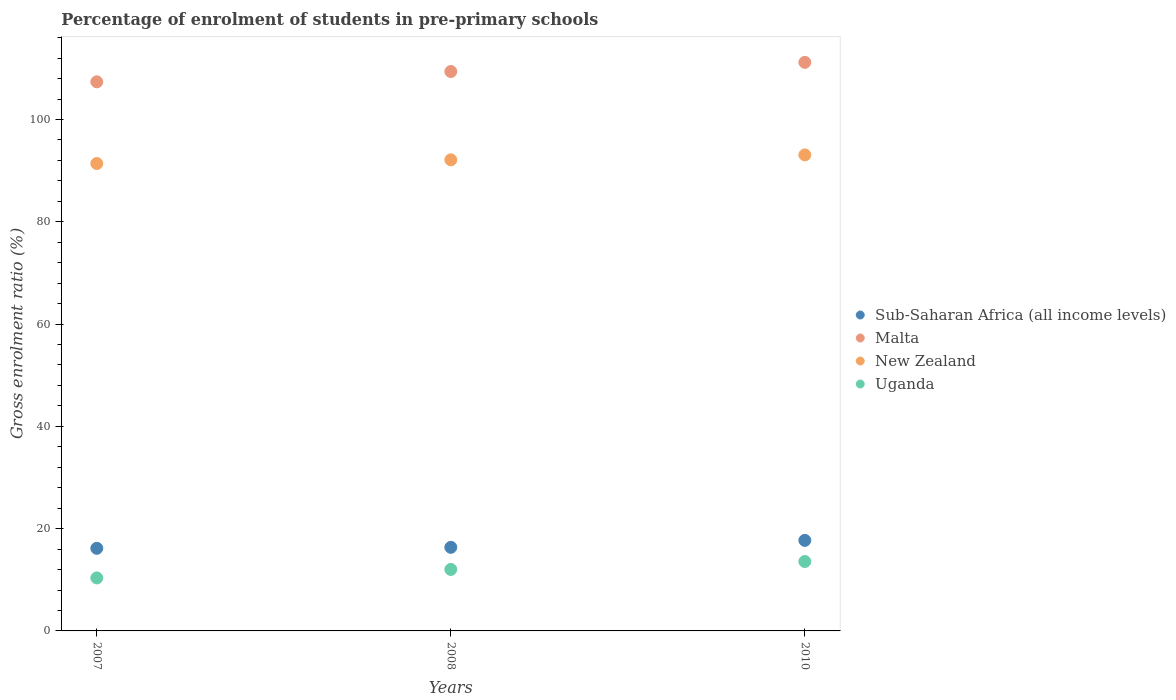How many different coloured dotlines are there?
Offer a very short reply. 4. What is the percentage of students enrolled in pre-primary schools in Uganda in 2010?
Ensure brevity in your answer.  13.57. Across all years, what is the maximum percentage of students enrolled in pre-primary schools in Uganda?
Provide a short and direct response. 13.57. Across all years, what is the minimum percentage of students enrolled in pre-primary schools in Sub-Saharan Africa (all income levels)?
Ensure brevity in your answer.  16.16. In which year was the percentage of students enrolled in pre-primary schools in New Zealand maximum?
Offer a terse response. 2010. What is the total percentage of students enrolled in pre-primary schools in Sub-Saharan Africa (all income levels) in the graph?
Provide a short and direct response. 50.2. What is the difference between the percentage of students enrolled in pre-primary schools in New Zealand in 2007 and that in 2008?
Your response must be concise. -0.72. What is the difference between the percentage of students enrolled in pre-primary schools in Uganda in 2010 and the percentage of students enrolled in pre-primary schools in Sub-Saharan Africa (all income levels) in 2007?
Keep it short and to the point. -2.58. What is the average percentage of students enrolled in pre-primary schools in Uganda per year?
Make the answer very short. 11.99. In the year 2007, what is the difference between the percentage of students enrolled in pre-primary schools in Sub-Saharan Africa (all income levels) and percentage of students enrolled in pre-primary schools in New Zealand?
Give a very brief answer. -75.24. What is the ratio of the percentage of students enrolled in pre-primary schools in Uganda in 2007 to that in 2008?
Make the answer very short. 0.86. Is the difference between the percentage of students enrolled in pre-primary schools in Sub-Saharan Africa (all income levels) in 2007 and 2008 greater than the difference between the percentage of students enrolled in pre-primary schools in New Zealand in 2007 and 2008?
Make the answer very short. Yes. What is the difference between the highest and the second highest percentage of students enrolled in pre-primary schools in Sub-Saharan Africa (all income levels)?
Give a very brief answer. 1.36. What is the difference between the highest and the lowest percentage of students enrolled in pre-primary schools in New Zealand?
Provide a succinct answer. 1.68. Is it the case that in every year, the sum of the percentage of students enrolled in pre-primary schools in Sub-Saharan Africa (all income levels) and percentage of students enrolled in pre-primary schools in New Zealand  is greater than the sum of percentage of students enrolled in pre-primary schools in Uganda and percentage of students enrolled in pre-primary schools in Malta?
Provide a short and direct response. No. Does the percentage of students enrolled in pre-primary schools in Malta monotonically increase over the years?
Ensure brevity in your answer.  Yes. Is the percentage of students enrolled in pre-primary schools in New Zealand strictly greater than the percentage of students enrolled in pre-primary schools in Uganda over the years?
Offer a terse response. Yes. Is the percentage of students enrolled in pre-primary schools in Uganda strictly less than the percentage of students enrolled in pre-primary schools in Sub-Saharan Africa (all income levels) over the years?
Ensure brevity in your answer.  Yes. Are the values on the major ticks of Y-axis written in scientific E-notation?
Your answer should be compact. No. Does the graph contain any zero values?
Give a very brief answer. No. Where does the legend appear in the graph?
Your answer should be very brief. Center right. What is the title of the graph?
Offer a terse response. Percentage of enrolment of students in pre-primary schools. What is the Gross enrolment ratio (%) of Sub-Saharan Africa (all income levels) in 2007?
Give a very brief answer. 16.16. What is the Gross enrolment ratio (%) of Malta in 2007?
Your response must be concise. 107.37. What is the Gross enrolment ratio (%) of New Zealand in 2007?
Provide a short and direct response. 91.4. What is the Gross enrolment ratio (%) of Uganda in 2007?
Make the answer very short. 10.36. What is the Gross enrolment ratio (%) of Sub-Saharan Africa (all income levels) in 2008?
Your answer should be very brief. 16.34. What is the Gross enrolment ratio (%) of Malta in 2008?
Give a very brief answer. 109.39. What is the Gross enrolment ratio (%) in New Zealand in 2008?
Your answer should be compact. 92.12. What is the Gross enrolment ratio (%) in Uganda in 2008?
Provide a short and direct response. 12.02. What is the Gross enrolment ratio (%) of Sub-Saharan Africa (all income levels) in 2010?
Your answer should be compact. 17.7. What is the Gross enrolment ratio (%) in Malta in 2010?
Give a very brief answer. 111.18. What is the Gross enrolment ratio (%) in New Zealand in 2010?
Your answer should be very brief. 93.08. What is the Gross enrolment ratio (%) of Uganda in 2010?
Keep it short and to the point. 13.57. Across all years, what is the maximum Gross enrolment ratio (%) of Sub-Saharan Africa (all income levels)?
Keep it short and to the point. 17.7. Across all years, what is the maximum Gross enrolment ratio (%) in Malta?
Offer a very short reply. 111.18. Across all years, what is the maximum Gross enrolment ratio (%) of New Zealand?
Ensure brevity in your answer.  93.08. Across all years, what is the maximum Gross enrolment ratio (%) of Uganda?
Give a very brief answer. 13.57. Across all years, what is the minimum Gross enrolment ratio (%) in Sub-Saharan Africa (all income levels)?
Offer a terse response. 16.16. Across all years, what is the minimum Gross enrolment ratio (%) of Malta?
Your answer should be very brief. 107.37. Across all years, what is the minimum Gross enrolment ratio (%) in New Zealand?
Offer a terse response. 91.4. Across all years, what is the minimum Gross enrolment ratio (%) of Uganda?
Your response must be concise. 10.36. What is the total Gross enrolment ratio (%) in Sub-Saharan Africa (all income levels) in the graph?
Provide a succinct answer. 50.2. What is the total Gross enrolment ratio (%) in Malta in the graph?
Provide a short and direct response. 327.93. What is the total Gross enrolment ratio (%) in New Zealand in the graph?
Your answer should be compact. 276.6. What is the total Gross enrolment ratio (%) of Uganda in the graph?
Provide a succinct answer. 35.96. What is the difference between the Gross enrolment ratio (%) of Sub-Saharan Africa (all income levels) in 2007 and that in 2008?
Your answer should be very brief. -0.19. What is the difference between the Gross enrolment ratio (%) in Malta in 2007 and that in 2008?
Provide a short and direct response. -2.02. What is the difference between the Gross enrolment ratio (%) in New Zealand in 2007 and that in 2008?
Keep it short and to the point. -0.72. What is the difference between the Gross enrolment ratio (%) in Uganda in 2007 and that in 2008?
Provide a succinct answer. -1.66. What is the difference between the Gross enrolment ratio (%) in Sub-Saharan Africa (all income levels) in 2007 and that in 2010?
Make the answer very short. -1.55. What is the difference between the Gross enrolment ratio (%) in Malta in 2007 and that in 2010?
Ensure brevity in your answer.  -3.81. What is the difference between the Gross enrolment ratio (%) in New Zealand in 2007 and that in 2010?
Make the answer very short. -1.68. What is the difference between the Gross enrolment ratio (%) in Uganda in 2007 and that in 2010?
Offer a terse response. -3.21. What is the difference between the Gross enrolment ratio (%) in Sub-Saharan Africa (all income levels) in 2008 and that in 2010?
Ensure brevity in your answer.  -1.36. What is the difference between the Gross enrolment ratio (%) in Malta in 2008 and that in 2010?
Make the answer very short. -1.79. What is the difference between the Gross enrolment ratio (%) in New Zealand in 2008 and that in 2010?
Offer a very short reply. -0.96. What is the difference between the Gross enrolment ratio (%) of Uganda in 2008 and that in 2010?
Provide a short and direct response. -1.55. What is the difference between the Gross enrolment ratio (%) of Sub-Saharan Africa (all income levels) in 2007 and the Gross enrolment ratio (%) of Malta in 2008?
Offer a terse response. -93.23. What is the difference between the Gross enrolment ratio (%) in Sub-Saharan Africa (all income levels) in 2007 and the Gross enrolment ratio (%) in New Zealand in 2008?
Your answer should be very brief. -75.96. What is the difference between the Gross enrolment ratio (%) of Sub-Saharan Africa (all income levels) in 2007 and the Gross enrolment ratio (%) of Uganda in 2008?
Ensure brevity in your answer.  4.13. What is the difference between the Gross enrolment ratio (%) of Malta in 2007 and the Gross enrolment ratio (%) of New Zealand in 2008?
Offer a terse response. 15.25. What is the difference between the Gross enrolment ratio (%) of Malta in 2007 and the Gross enrolment ratio (%) of Uganda in 2008?
Offer a very short reply. 95.35. What is the difference between the Gross enrolment ratio (%) in New Zealand in 2007 and the Gross enrolment ratio (%) in Uganda in 2008?
Keep it short and to the point. 79.37. What is the difference between the Gross enrolment ratio (%) in Sub-Saharan Africa (all income levels) in 2007 and the Gross enrolment ratio (%) in Malta in 2010?
Offer a very short reply. -95.02. What is the difference between the Gross enrolment ratio (%) in Sub-Saharan Africa (all income levels) in 2007 and the Gross enrolment ratio (%) in New Zealand in 2010?
Your answer should be very brief. -76.93. What is the difference between the Gross enrolment ratio (%) of Sub-Saharan Africa (all income levels) in 2007 and the Gross enrolment ratio (%) of Uganda in 2010?
Give a very brief answer. 2.58. What is the difference between the Gross enrolment ratio (%) of Malta in 2007 and the Gross enrolment ratio (%) of New Zealand in 2010?
Give a very brief answer. 14.29. What is the difference between the Gross enrolment ratio (%) in Malta in 2007 and the Gross enrolment ratio (%) in Uganda in 2010?
Your answer should be compact. 93.8. What is the difference between the Gross enrolment ratio (%) in New Zealand in 2007 and the Gross enrolment ratio (%) in Uganda in 2010?
Provide a succinct answer. 77.83. What is the difference between the Gross enrolment ratio (%) in Sub-Saharan Africa (all income levels) in 2008 and the Gross enrolment ratio (%) in Malta in 2010?
Provide a short and direct response. -94.83. What is the difference between the Gross enrolment ratio (%) of Sub-Saharan Africa (all income levels) in 2008 and the Gross enrolment ratio (%) of New Zealand in 2010?
Offer a very short reply. -76.74. What is the difference between the Gross enrolment ratio (%) of Sub-Saharan Africa (all income levels) in 2008 and the Gross enrolment ratio (%) of Uganda in 2010?
Offer a very short reply. 2.77. What is the difference between the Gross enrolment ratio (%) of Malta in 2008 and the Gross enrolment ratio (%) of New Zealand in 2010?
Keep it short and to the point. 16.31. What is the difference between the Gross enrolment ratio (%) in Malta in 2008 and the Gross enrolment ratio (%) in Uganda in 2010?
Keep it short and to the point. 95.82. What is the difference between the Gross enrolment ratio (%) of New Zealand in 2008 and the Gross enrolment ratio (%) of Uganda in 2010?
Your answer should be very brief. 78.55. What is the average Gross enrolment ratio (%) of Sub-Saharan Africa (all income levels) per year?
Make the answer very short. 16.73. What is the average Gross enrolment ratio (%) of Malta per year?
Provide a short and direct response. 109.31. What is the average Gross enrolment ratio (%) of New Zealand per year?
Keep it short and to the point. 92.2. What is the average Gross enrolment ratio (%) of Uganda per year?
Your answer should be very brief. 11.99. In the year 2007, what is the difference between the Gross enrolment ratio (%) in Sub-Saharan Africa (all income levels) and Gross enrolment ratio (%) in Malta?
Provide a short and direct response. -91.21. In the year 2007, what is the difference between the Gross enrolment ratio (%) of Sub-Saharan Africa (all income levels) and Gross enrolment ratio (%) of New Zealand?
Your answer should be compact. -75.24. In the year 2007, what is the difference between the Gross enrolment ratio (%) in Sub-Saharan Africa (all income levels) and Gross enrolment ratio (%) in Uganda?
Ensure brevity in your answer.  5.79. In the year 2007, what is the difference between the Gross enrolment ratio (%) in Malta and Gross enrolment ratio (%) in New Zealand?
Your answer should be compact. 15.97. In the year 2007, what is the difference between the Gross enrolment ratio (%) in Malta and Gross enrolment ratio (%) in Uganda?
Make the answer very short. 97.01. In the year 2007, what is the difference between the Gross enrolment ratio (%) of New Zealand and Gross enrolment ratio (%) of Uganda?
Give a very brief answer. 81.03. In the year 2008, what is the difference between the Gross enrolment ratio (%) of Sub-Saharan Africa (all income levels) and Gross enrolment ratio (%) of Malta?
Provide a short and direct response. -93.04. In the year 2008, what is the difference between the Gross enrolment ratio (%) in Sub-Saharan Africa (all income levels) and Gross enrolment ratio (%) in New Zealand?
Offer a very short reply. -75.77. In the year 2008, what is the difference between the Gross enrolment ratio (%) of Sub-Saharan Africa (all income levels) and Gross enrolment ratio (%) of Uganda?
Your answer should be very brief. 4.32. In the year 2008, what is the difference between the Gross enrolment ratio (%) of Malta and Gross enrolment ratio (%) of New Zealand?
Keep it short and to the point. 17.27. In the year 2008, what is the difference between the Gross enrolment ratio (%) of Malta and Gross enrolment ratio (%) of Uganda?
Keep it short and to the point. 97.36. In the year 2008, what is the difference between the Gross enrolment ratio (%) in New Zealand and Gross enrolment ratio (%) in Uganda?
Provide a succinct answer. 80.1. In the year 2010, what is the difference between the Gross enrolment ratio (%) in Sub-Saharan Africa (all income levels) and Gross enrolment ratio (%) in Malta?
Offer a very short reply. -93.47. In the year 2010, what is the difference between the Gross enrolment ratio (%) in Sub-Saharan Africa (all income levels) and Gross enrolment ratio (%) in New Zealand?
Offer a very short reply. -75.38. In the year 2010, what is the difference between the Gross enrolment ratio (%) in Sub-Saharan Africa (all income levels) and Gross enrolment ratio (%) in Uganda?
Offer a very short reply. 4.13. In the year 2010, what is the difference between the Gross enrolment ratio (%) in Malta and Gross enrolment ratio (%) in New Zealand?
Your answer should be very brief. 18.1. In the year 2010, what is the difference between the Gross enrolment ratio (%) in Malta and Gross enrolment ratio (%) in Uganda?
Your answer should be very brief. 97.61. In the year 2010, what is the difference between the Gross enrolment ratio (%) in New Zealand and Gross enrolment ratio (%) in Uganda?
Provide a short and direct response. 79.51. What is the ratio of the Gross enrolment ratio (%) in Malta in 2007 to that in 2008?
Your answer should be compact. 0.98. What is the ratio of the Gross enrolment ratio (%) in Uganda in 2007 to that in 2008?
Provide a succinct answer. 0.86. What is the ratio of the Gross enrolment ratio (%) in Sub-Saharan Africa (all income levels) in 2007 to that in 2010?
Keep it short and to the point. 0.91. What is the ratio of the Gross enrolment ratio (%) of Malta in 2007 to that in 2010?
Provide a short and direct response. 0.97. What is the ratio of the Gross enrolment ratio (%) of New Zealand in 2007 to that in 2010?
Keep it short and to the point. 0.98. What is the ratio of the Gross enrolment ratio (%) of Uganda in 2007 to that in 2010?
Offer a very short reply. 0.76. What is the ratio of the Gross enrolment ratio (%) in Sub-Saharan Africa (all income levels) in 2008 to that in 2010?
Make the answer very short. 0.92. What is the ratio of the Gross enrolment ratio (%) in Malta in 2008 to that in 2010?
Your answer should be compact. 0.98. What is the ratio of the Gross enrolment ratio (%) of Uganda in 2008 to that in 2010?
Your answer should be compact. 0.89. What is the difference between the highest and the second highest Gross enrolment ratio (%) in Sub-Saharan Africa (all income levels)?
Offer a very short reply. 1.36. What is the difference between the highest and the second highest Gross enrolment ratio (%) of Malta?
Your response must be concise. 1.79. What is the difference between the highest and the second highest Gross enrolment ratio (%) of New Zealand?
Your answer should be very brief. 0.96. What is the difference between the highest and the second highest Gross enrolment ratio (%) of Uganda?
Your response must be concise. 1.55. What is the difference between the highest and the lowest Gross enrolment ratio (%) in Sub-Saharan Africa (all income levels)?
Provide a succinct answer. 1.55. What is the difference between the highest and the lowest Gross enrolment ratio (%) in Malta?
Make the answer very short. 3.81. What is the difference between the highest and the lowest Gross enrolment ratio (%) in New Zealand?
Provide a succinct answer. 1.68. What is the difference between the highest and the lowest Gross enrolment ratio (%) in Uganda?
Your answer should be very brief. 3.21. 